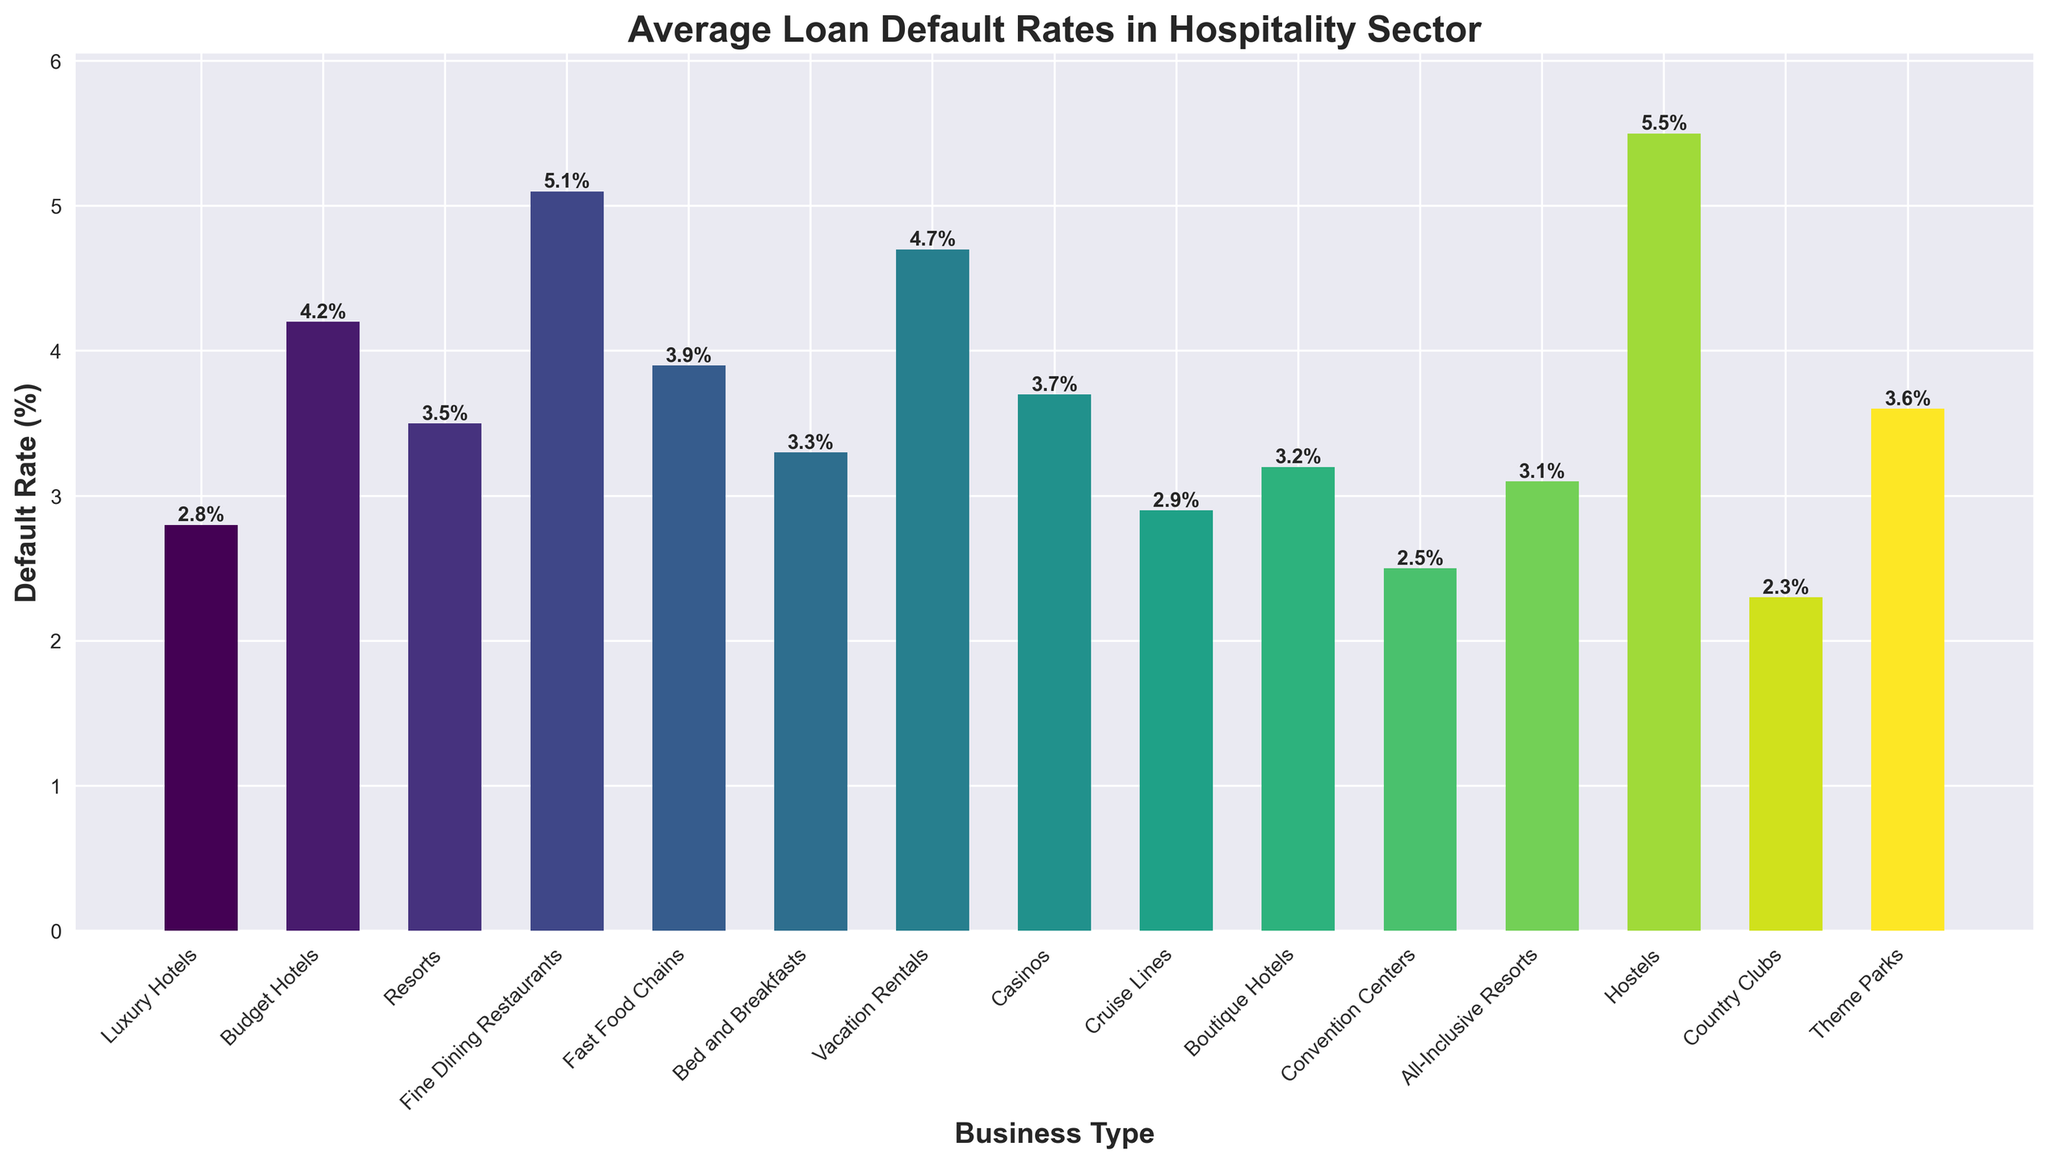Which type of hospitality business has the highest default rate? The highest default rate can be identified by looking for the tallest bar in the bar chart. Upon inspection, the bar representing "Hostels" is the tallest.
Answer: Hostels Which type of hospitality business has the lowest default rate? The lowest default rate can be identified by looking for the shortest bar in the bar chart. The bar representing "Country Clubs" is the shortest.
Answer: Country Clubs What is the difference in default rates between Luxury Hotels and Budget Hotels? The default rate for Luxury Hotels is 2.8% and for Budget Hotels is 4.2%. The difference is 4.2% - 2.8%.
Answer: 1.4% How many business types have default rates below 3%? Counting the bars with heights below 3%, there are four such business types: Luxury Hotels, Cruise Lines, Convention Centers, and Country Clubs.
Answer: 4 Which types of hospitality businesses have default rates above 4%? Looking for bars with heights above the 4% mark, we find that Budget Hotels, Fine Dining Restaurants, Vacation Rentals, and Hostels have default rates above 4%.
Answer: Budget Hotels, Fine Dining Restaurants, Vacation Rentals, Hostels Is the default rate for Theme Parks higher or lower than that for Resorts? The default rate for Theme Parks is 3.6%, while for Resorts it is 3.5%. Since 3.6% > 3.5%, Theme Parks have a higher default rate than Resorts.
Answer: Higher What are the average default rates of the types of hospitality businesses with default rates under 3%? Summing up the default rates for Luxury Hotels (2.8%), Cruise Lines (2.9%), Convention Centers (2.5%), and Country Clubs (2.3%) first. The sum is 2.8 + 2.9 + 2.5 + 2.3 = 10.5%. Dividing this by the number of business types (4) gives the average: 10.5% / 4 = 2.625%.
Answer: 2.625% Comparing Bed and Breakfasts and Boutique Hotels, which type has the higher default rate and by how much? Bed and Breakfasts have a default rate of 3.3%, and Boutique Hotels have a default rate of 3.2%. The difference is 3.3% - 3.2% = 0.1%, with Bed and Breakfasts having a slightly higher rate.
Answer: Bed and Breakfasts by 0.1% Which business type has a default rate closest to the overall average default rate of all the types listed? First, calculate the overall average default rate by summing all default rates and dividing by the number of types. Then compare each type's default rate to this average to find the closest. Sum of rates: 2.8 + 4.2 + 3.5 + 5.1 + 3.9 + 3.3 + 4.7 + 3.7 + 2.9 + 3.2 + 2.5 + 3.1 + 5.5 + 2.3 + 3.6 = 54.3%. Average rate: 54.3% / 15 = 3.62%. The business type closest to 3.62% is Theme Parks at 3.6%.
Answer: Theme Parks 